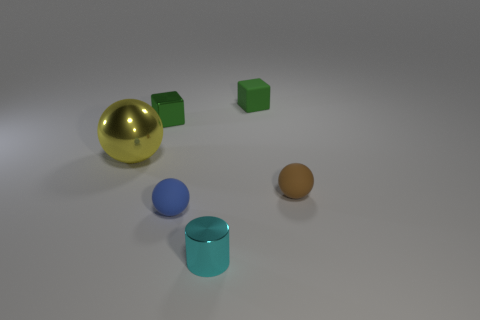There is another small green thing that is the same shape as the green matte thing; what is it made of?
Your response must be concise. Metal. How many big green shiny blocks are there?
Offer a very short reply. 0. There is a small matte object that is in front of the small brown sphere; what shape is it?
Provide a short and direct response. Sphere. There is a matte sphere that is behind the ball that is in front of the rubber thing right of the small green matte object; what color is it?
Offer a very short reply. Brown. The green thing that is the same material as the small brown ball is what shape?
Offer a very short reply. Cube. Are there fewer matte cubes than large green shiny cubes?
Your answer should be compact. No. Is the material of the yellow thing the same as the small brown object?
Give a very brief answer. No. What number of other things are there of the same color as the cylinder?
Provide a succinct answer. 0. Are there more small green rubber objects than big brown metallic cylinders?
Your response must be concise. Yes. There is a yellow object; is it the same size as the rubber object behind the yellow shiny thing?
Offer a very short reply. No. 